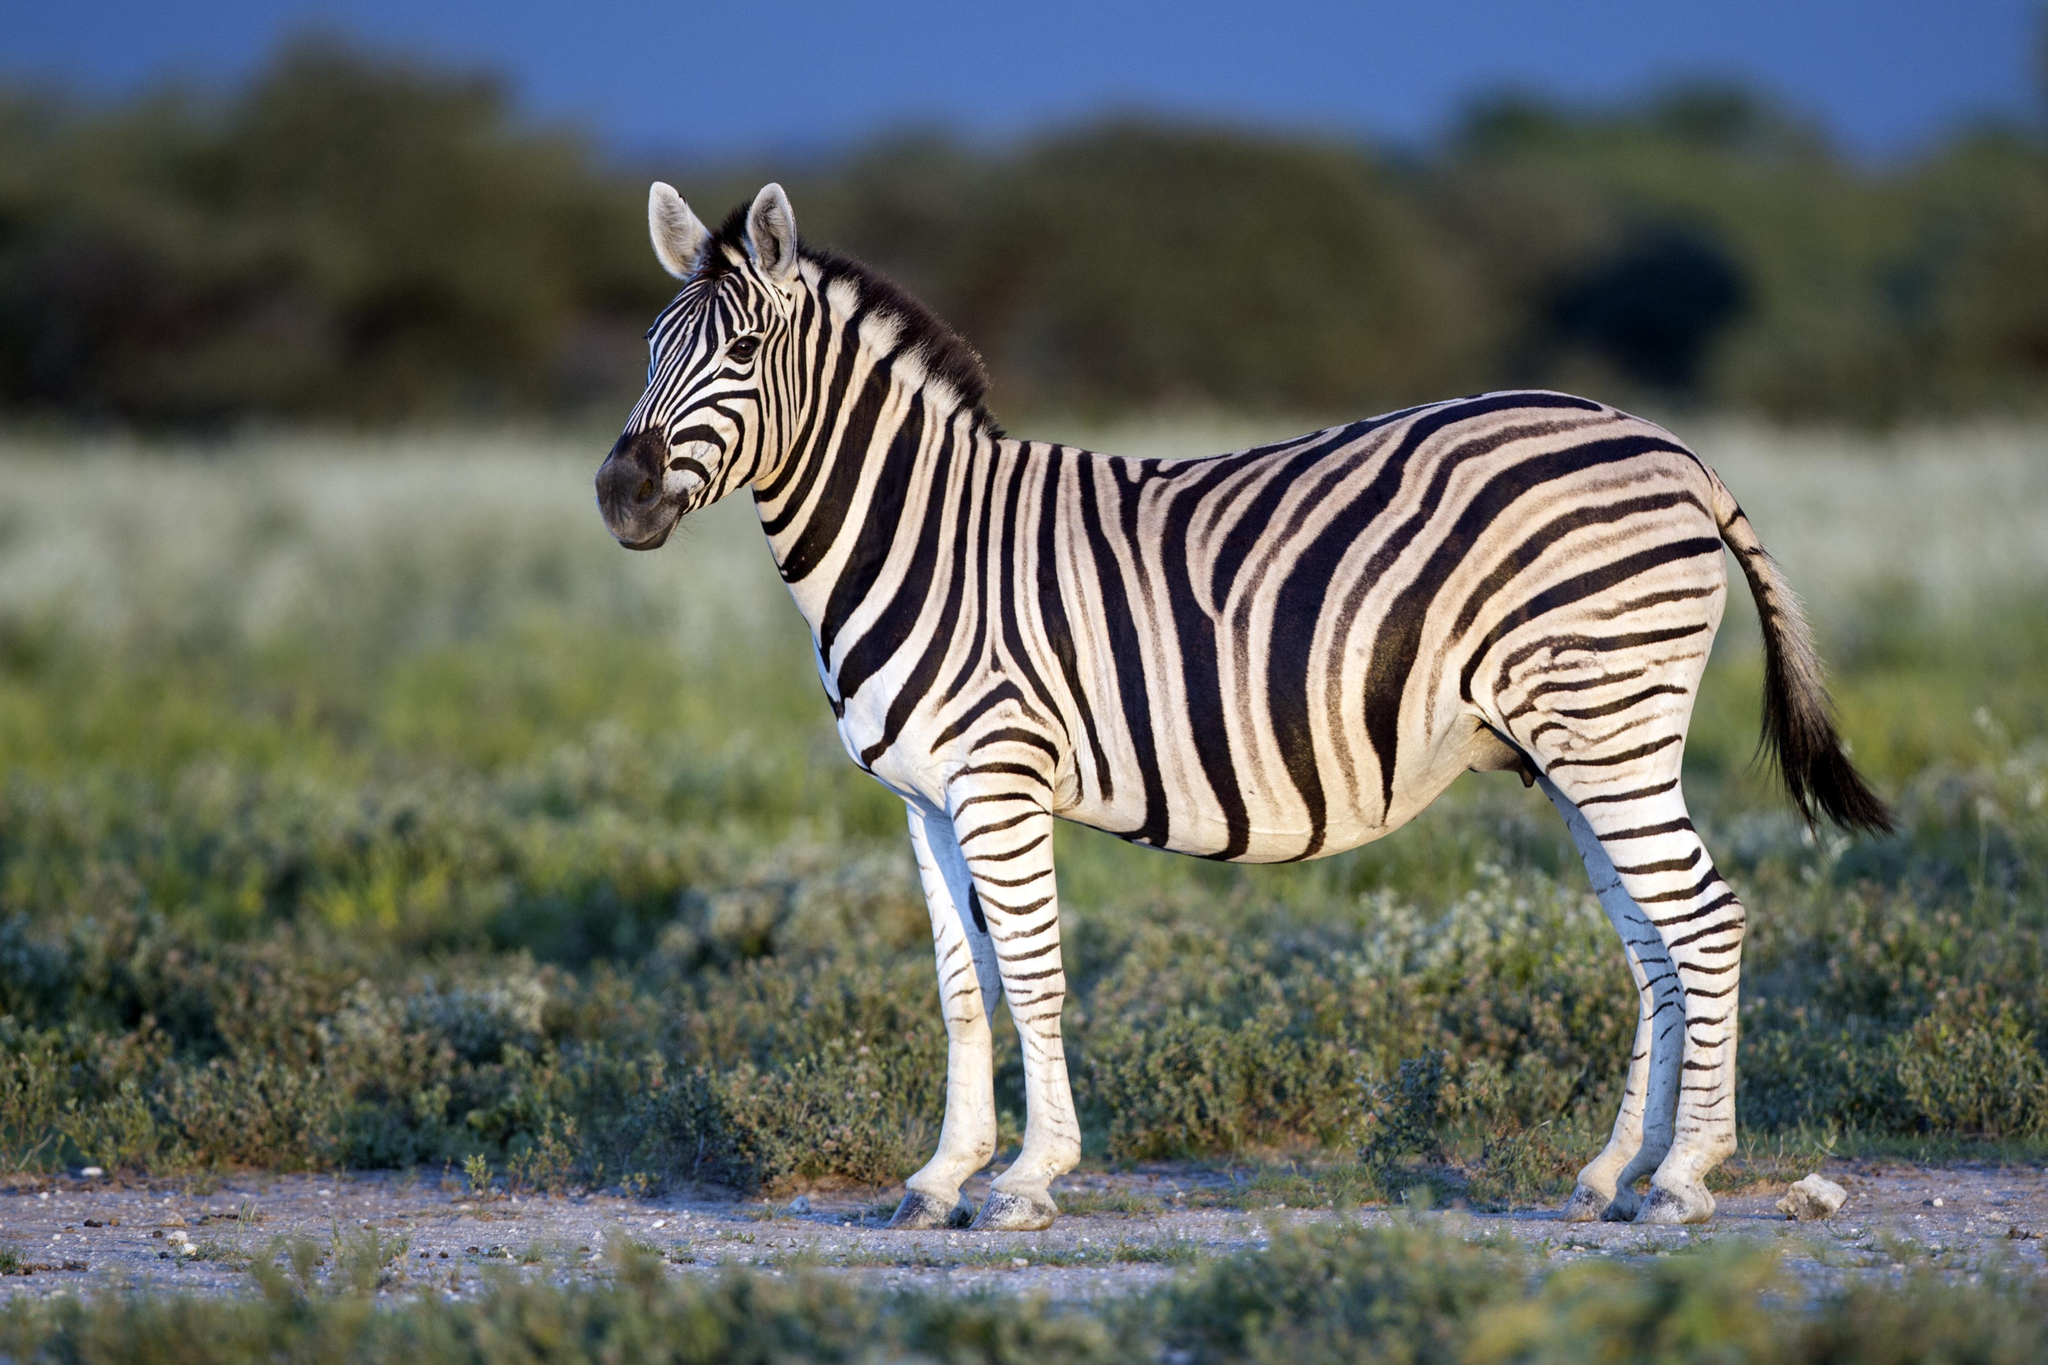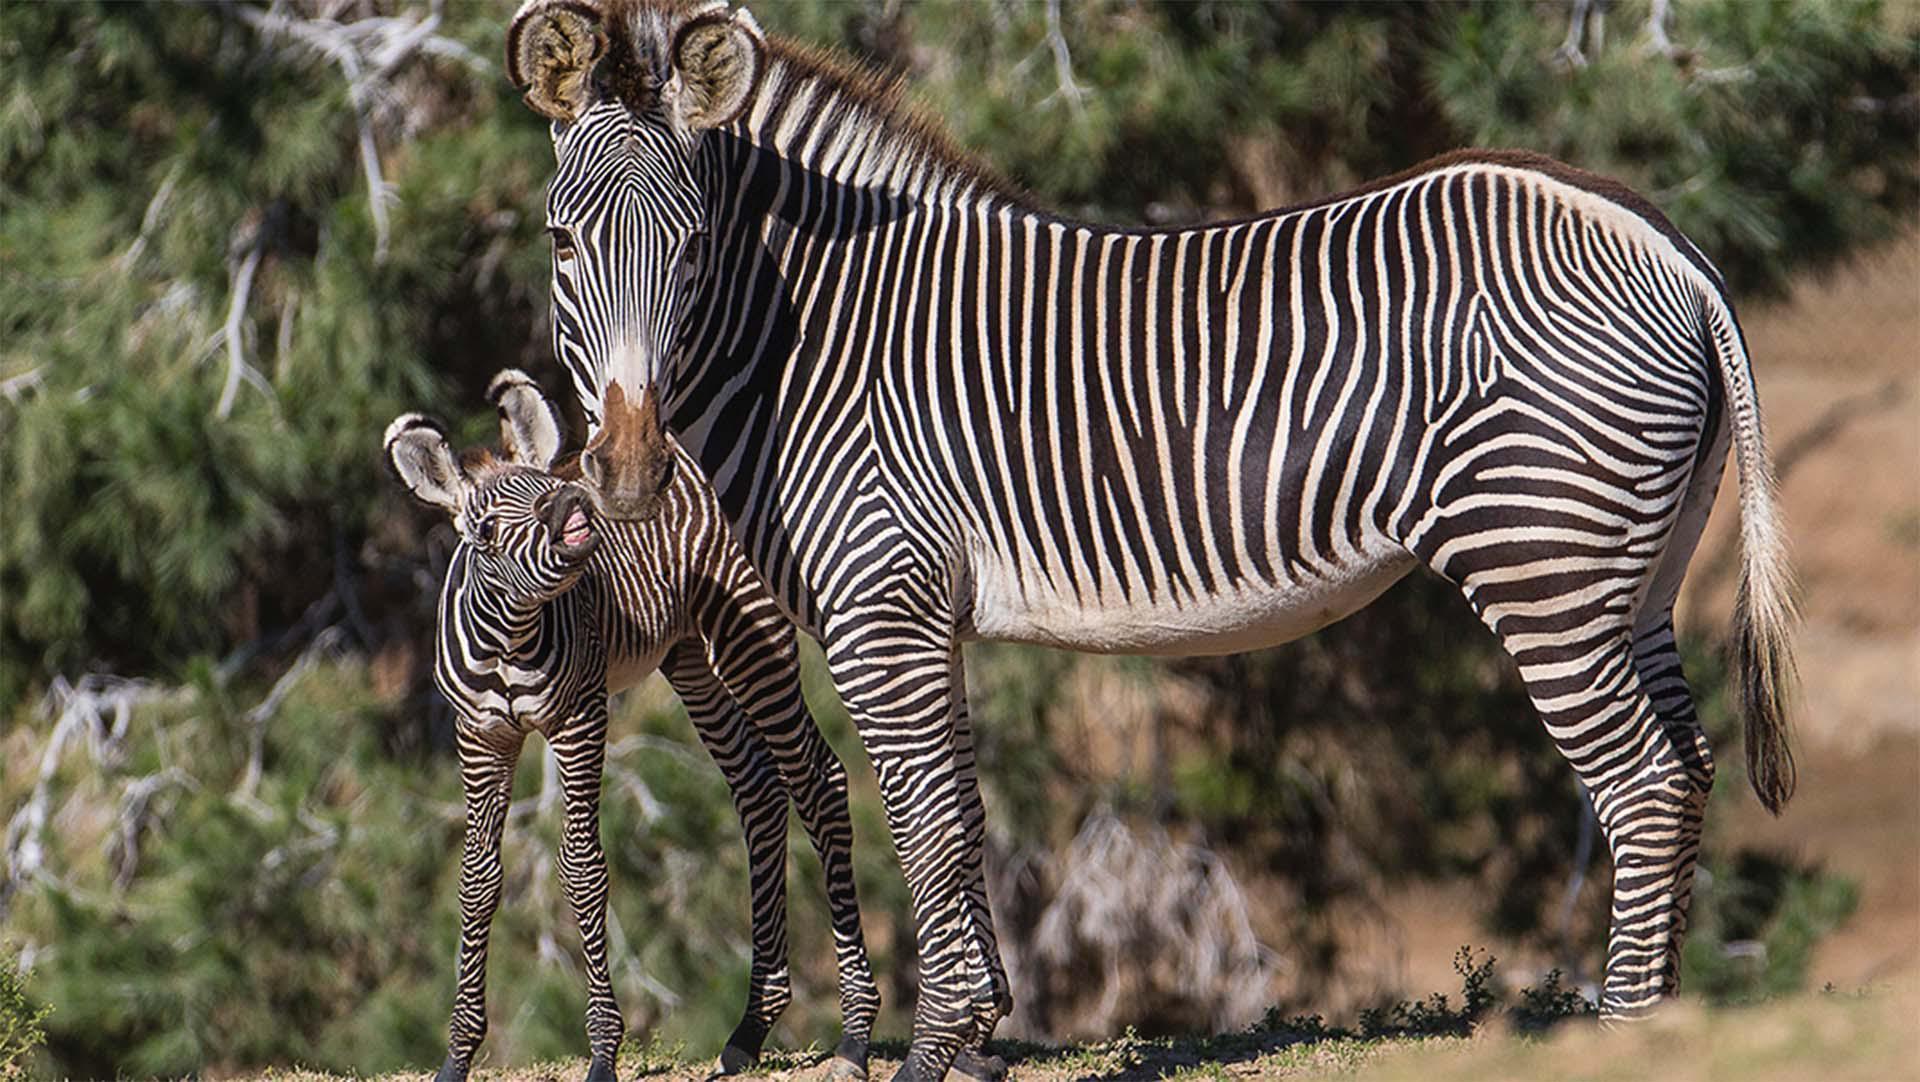The first image is the image on the left, the second image is the image on the right. Assess this claim about the two images: "There is a baby zebra standing next to an adult zebra.". Correct or not? Answer yes or no. Yes. The first image is the image on the left, the second image is the image on the right. For the images displayed, is the sentence "The zebras in both pictures are facing left." factually correct? Answer yes or no. Yes. 